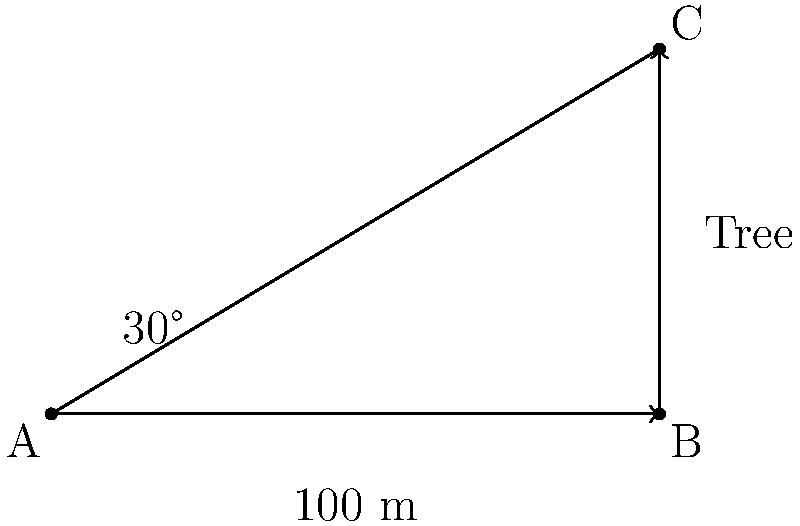During a forest canopy survey, you spot a tall tree at a distance of 100 meters. Using a clinometer, you measure the angle of elevation to the top of the tree as 30°. What is the approximate height of the tree? To solve this problem, we'll use trigonometry, specifically the tangent function. Let's break it down step-by-step:

1) In the right triangle formed by the observer, the base of the tree, and the top of the tree:
   - The adjacent side is the distance to the tree (100 m)
   - The opposite side is the height of the tree (what we're solving for)
   - The angle of elevation is 30°

2) The tangent of an angle in a right triangle is the ratio of the opposite side to the adjacent side:

   $$\tan(\theta) = \frac{\text{opposite}}{\text{adjacent}}$$

3) In this case:

   $$\tan(30°) = \frac{\text{tree height}}{100\text{ m}}$$

4) We can rearrange this to solve for the tree height:

   $$\text{tree height} = 100\text{ m} \times \tan(30°)$$

5) We know that $\tan(30°) = \frac{1}{\sqrt{3}} \approx 0.577$

6) Therefore:

   $$\text{tree height} = 100\text{ m} \times 0.577 = 57.7\text{ m}$$

Thus, the approximate height of the tree is 57.7 meters.
Answer: 57.7 meters 